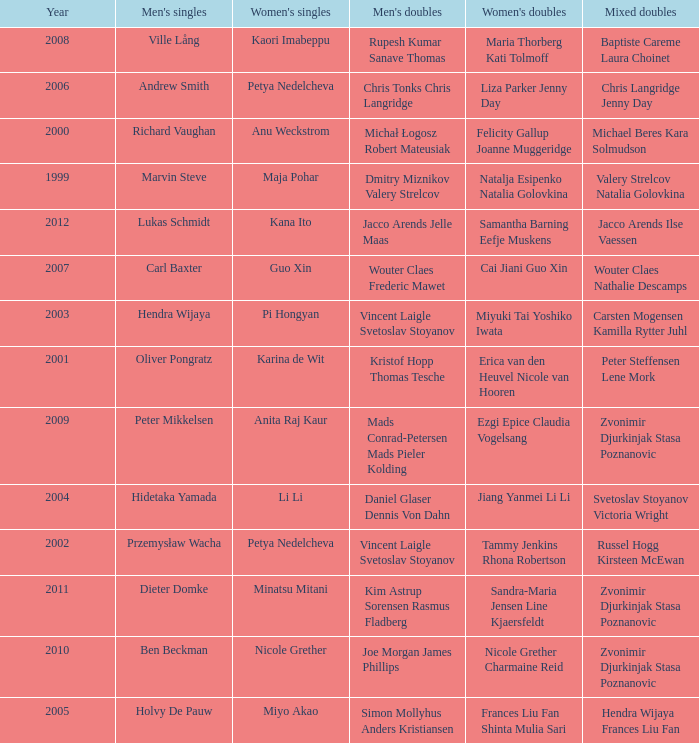What's the first year that Guo Xin featured in women's singles? 2007.0. 